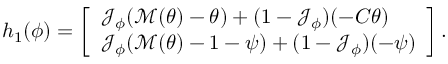<formula> <loc_0><loc_0><loc_500><loc_500>\begin{array} { r } { h _ { 1 } ( \phi ) = \left [ \begin{array} { l } { \mathcal { J } _ { \phi } ( \mathcal { M } ( \theta ) - \theta ) + ( 1 - \mathcal { J } _ { \phi } ) ( - C \theta ) } \\ { \mathcal { J } _ { \phi } ( \mathcal { M } ( \theta ) - 1 - \psi ) + ( 1 - \mathcal { J } _ { \phi } ) ( - \psi ) } \end{array} \right ] . } \end{array}</formula> 